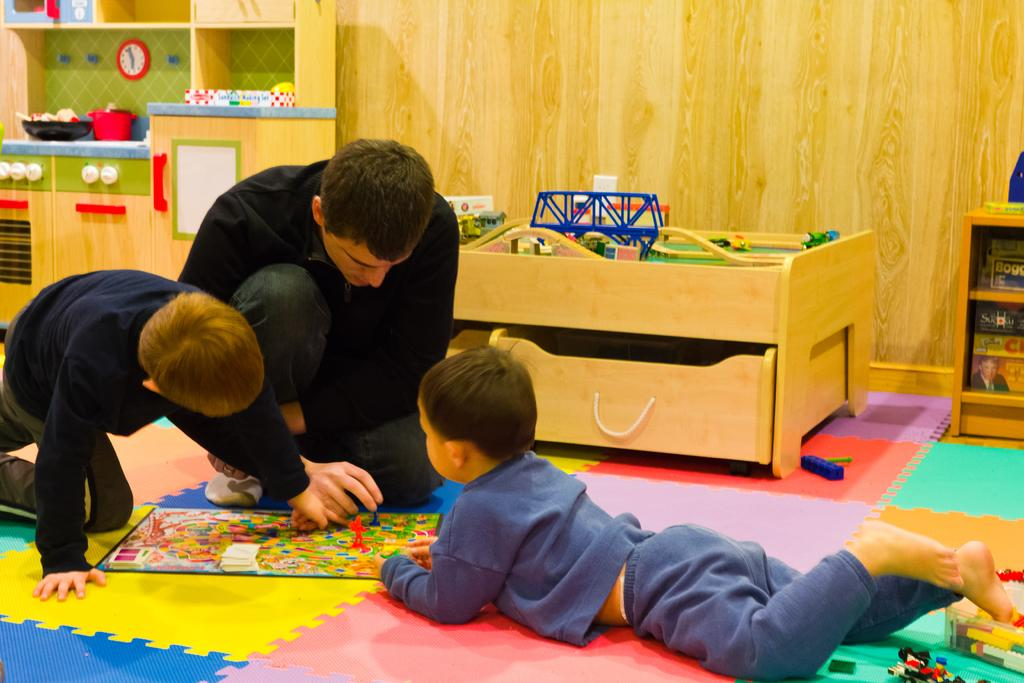What is the boy in the image doing? The boy is lying on the floor in the image. What activity can be seen on the left side of the image? Two persons are playing a game on the left side of the image. What type of wall is visible in the background of the image? There is a wooden wall visible in the background of the image. What type of pets are visible in the image? There are no pets visible in the image. 